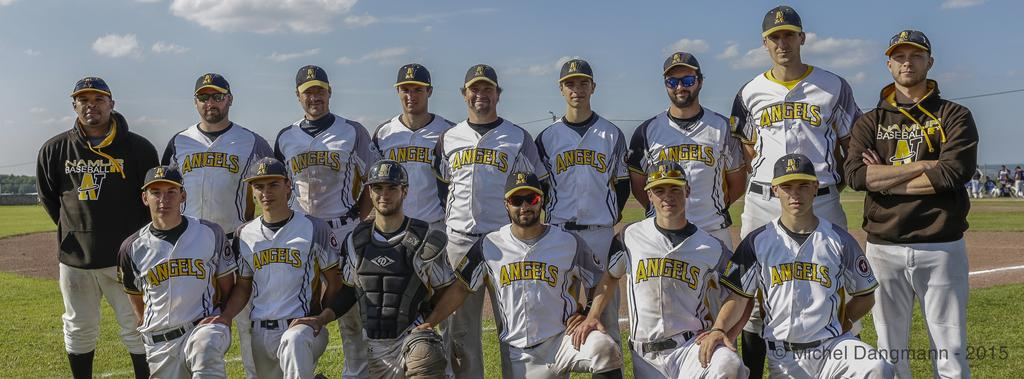<image>
Present a compact description of the photo's key features. Members of the Angels baseball team line up for a photo on the field. 